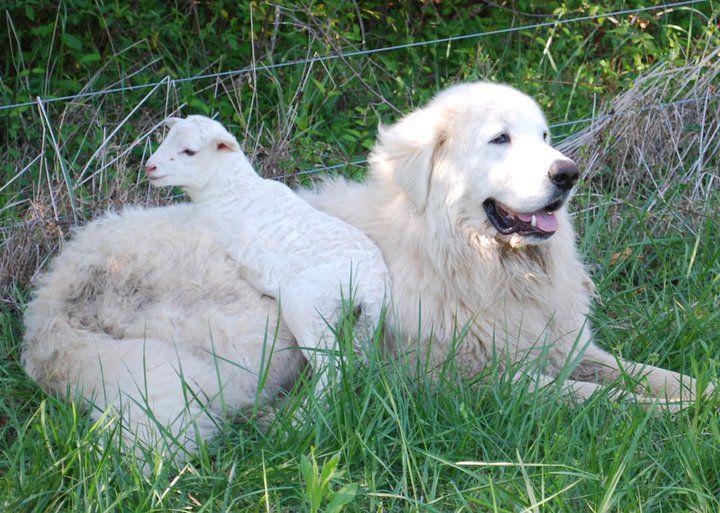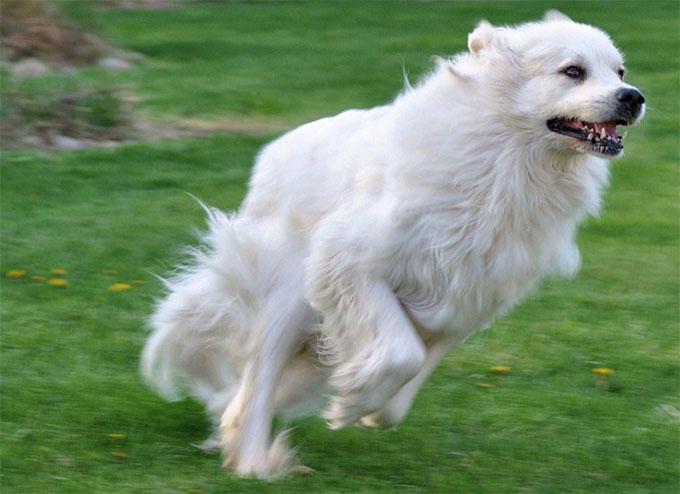The first image is the image on the left, the second image is the image on the right. Considering the images on both sides, is "There is exactly one dog and one goat in the image on the left." valid? Answer yes or no. Yes. 